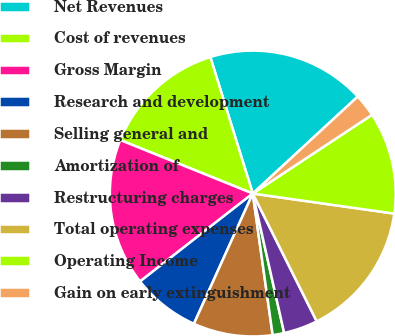<chart> <loc_0><loc_0><loc_500><loc_500><pie_chart><fcel>Net Revenues<fcel>Cost of revenues<fcel>Gross Margin<fcel>Research and development<fcel>Selling general and<fcel>Amortization of<fcel>Restructuring charges<fcel>Total operating expenses<fcel>Operating Income<fcel>Gain on early extinguishment<nl><fcel>17.93%<fcel>14.09%<fcel>16.65%<fcel>7.7%<fcel>8.98%<fcel>1.3%<fcel>3.86%<fcel>15.37%<fcel>11.53%<fcel>2.58%<nl></chart> 